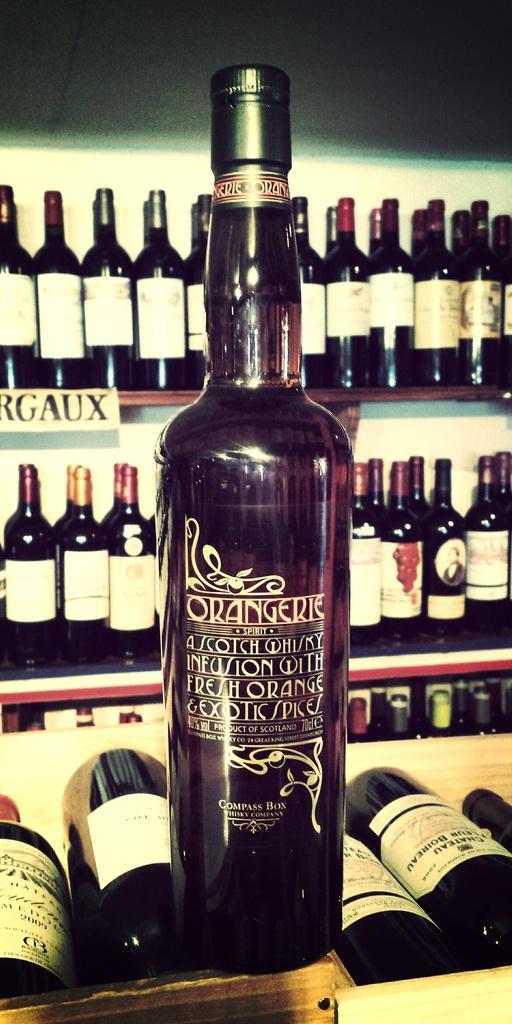What style of alcohol is displayed here?
Provide a succinct answer. Scotch whisky. In what country was the large bottle made?
Give a very brief answer. Scotland. 